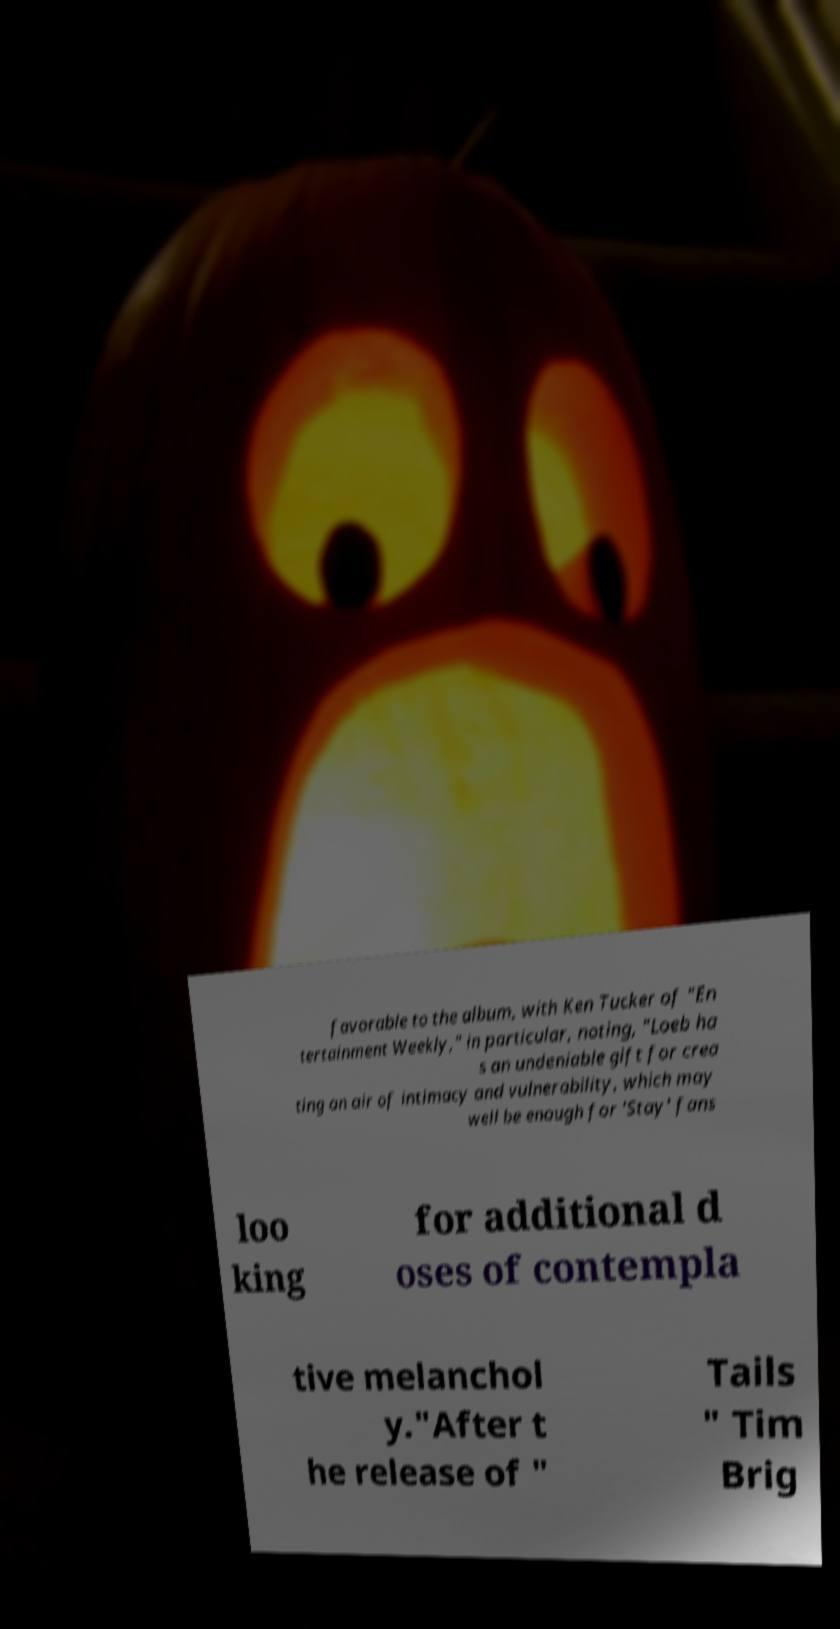Can you read and provide the text displayed in the image?This photo seems to have some interesting text. Can you extract and type it out for me? favorable to the album, with Ken Tucker of "En tertainment Weekly," in particular, noting, "Loeb ha s an undeniable gift for crea ting an air of intimacy and vulnerability, which may well be enough for 'Stay' fans loo king for additional d oses of contempla tive melanchol y."After t he release of " Tails " Tim Brig 